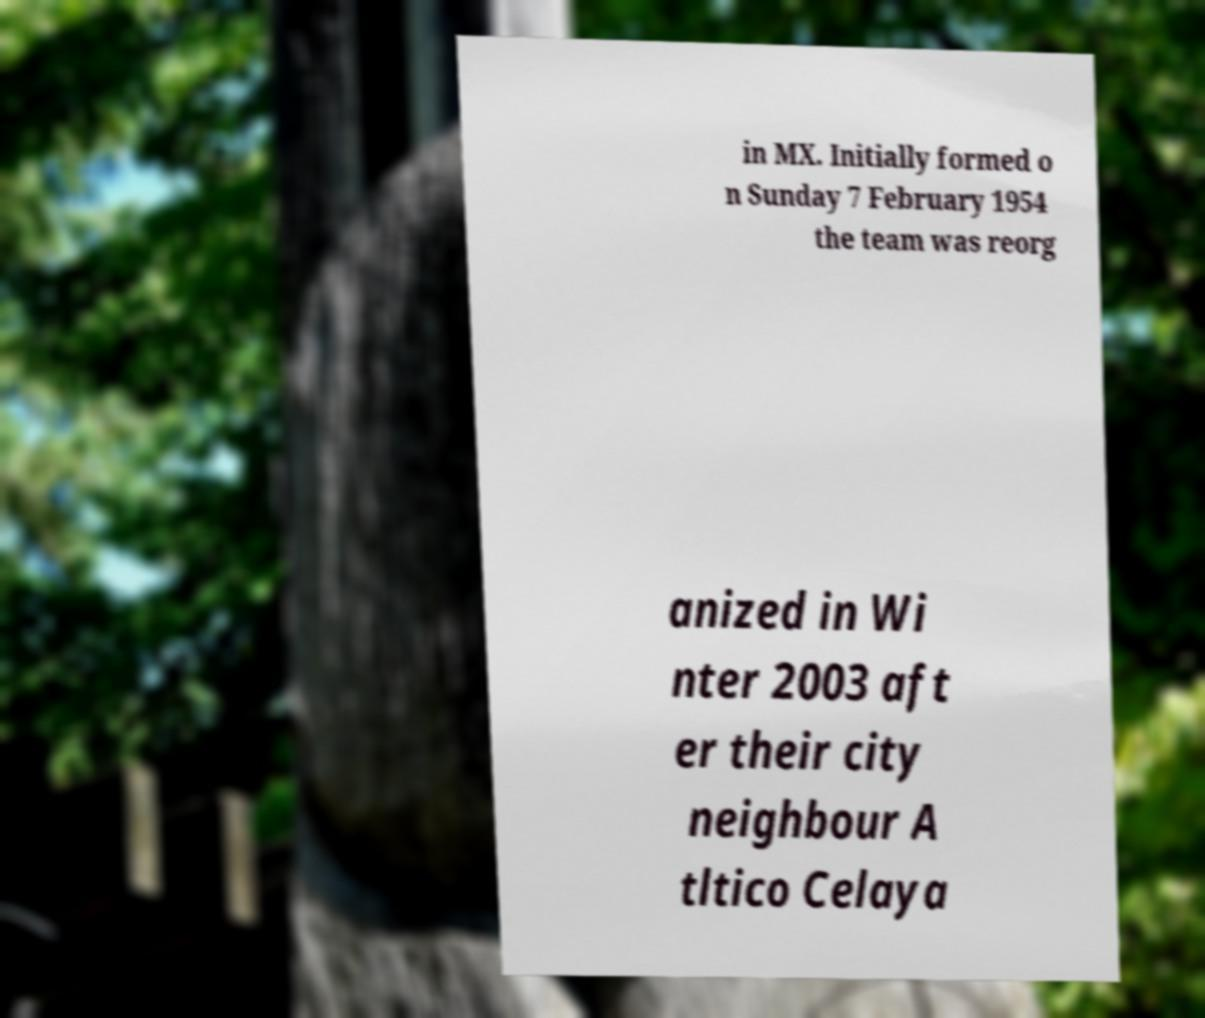Could you assist in decoding the text presented in this image and type it out clearly? in MX. Initially formed o n Sunday 7 February 1954 the team was reorg anized in Wi nter 2003 aft er their city neighbour A tltico Celaya 